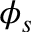<formula> <loc_0><loc_0><loc_500><loc_500>\phi _ { s }</formula> 